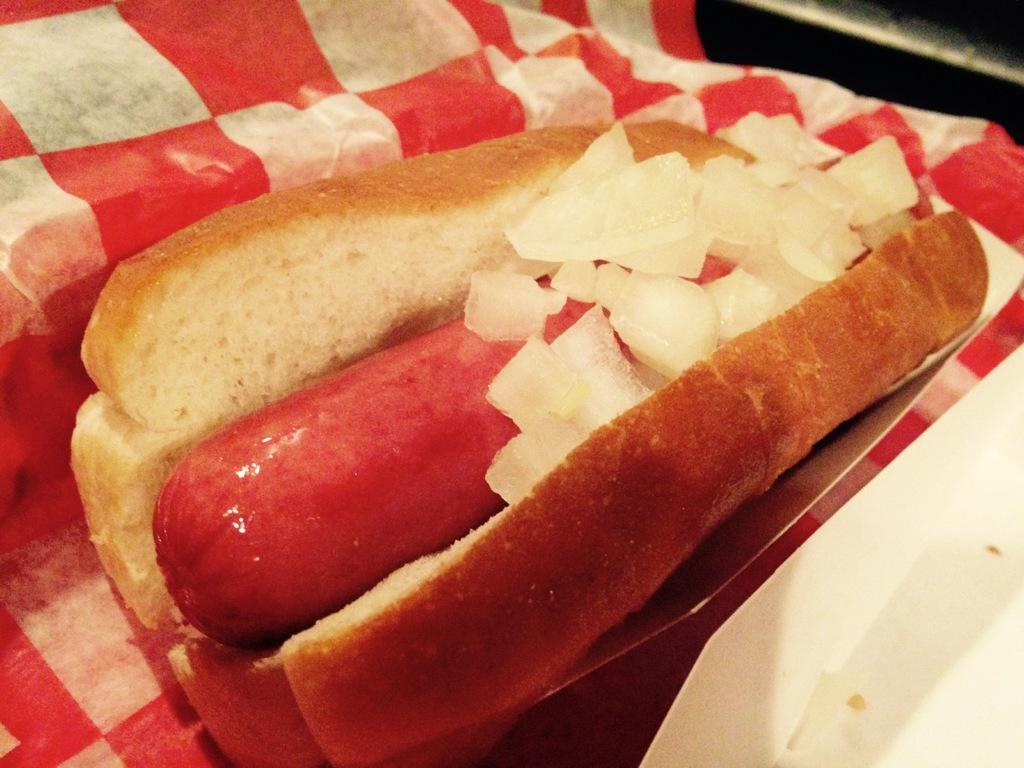What types of items can be seen in the image? There are food items and cloth in the image. Can you describe the food items in the image? Unfortunately, the specific food items are not mentioned in the provided facts. What can you tell me about the cloth in the image? The facts only mention that there is cloth in the image, but no further details are given. Are there any other objects in the image besides the food items and cloth? Yes, there are unspecified objects in the image. What is the account balance of the root in the image? There is no root or account balance mentioned in the image or the provided facts. 